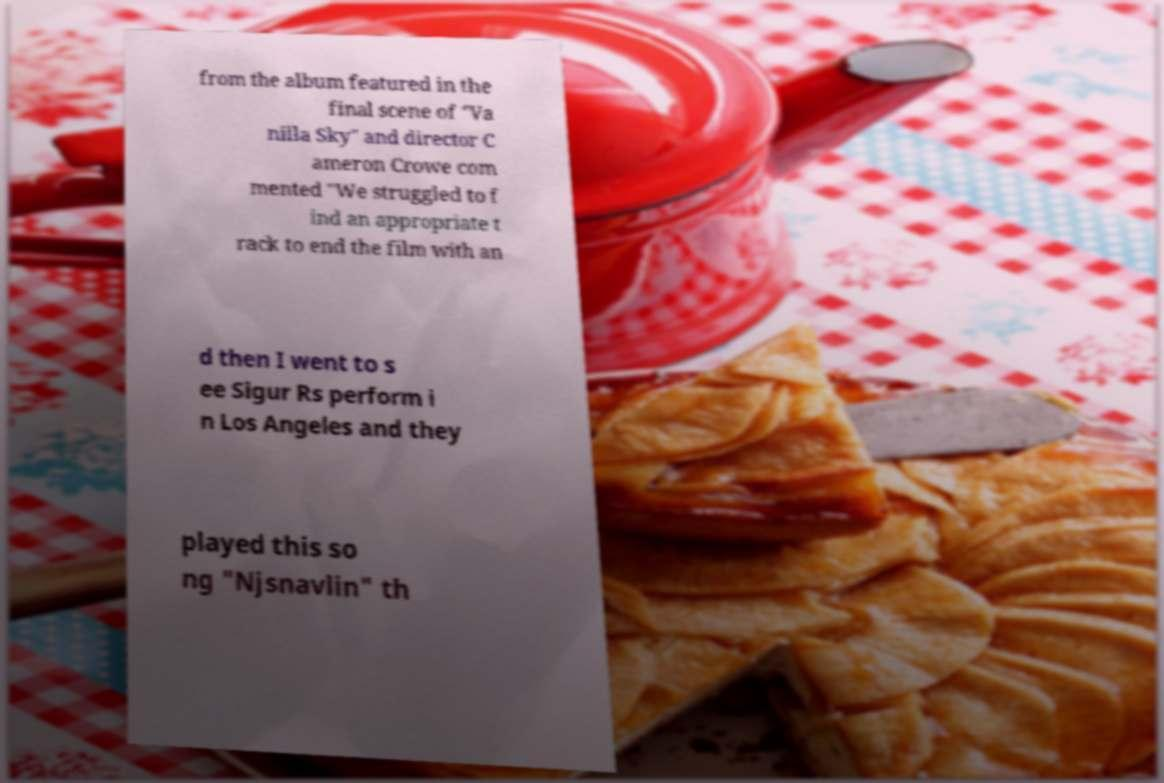Can you read and provide the text displayed in the image?This photo seems to have some interesting text. Can you extract and type it out for me? from the album featured in the final scene of "Va nilla Sky" and director C ameron Crowe com mented "We struggled to f ind an appropriate t rack to end the film with an d then I went to s ee Sigur Rs perform i n Los Angeles and they played this so ng "Njsnavlin" th 